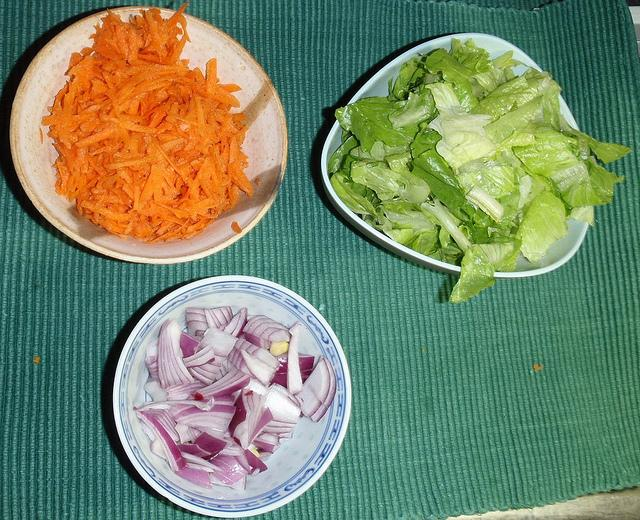What type of food are all of these? vegetables 